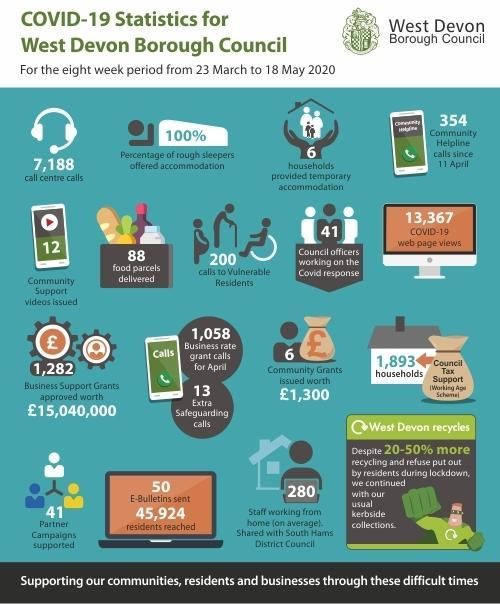How many community support videos were issued by the West Devon Borough Council as a part of Covid-19 response work from March 23- May 18 2020?
Answer the question with a short phrase. 12 How many households were provided with temporary accommodation by the West Devon Borough Council as a part of Covid-19 response work from March 23- May 18 2020? 6 How many food parcels were delivered by the West Devon Borough Council as a part of Covid-19 response work from March 23- May 18 2020? 88 How many council officers were working on the Covid response from March 23- May 18 2020? 41 What is the number of calls made to vulnerable people by the West Devon Borough Council as a part of Covid-19 response work from March 23- May 18 2020? 200 